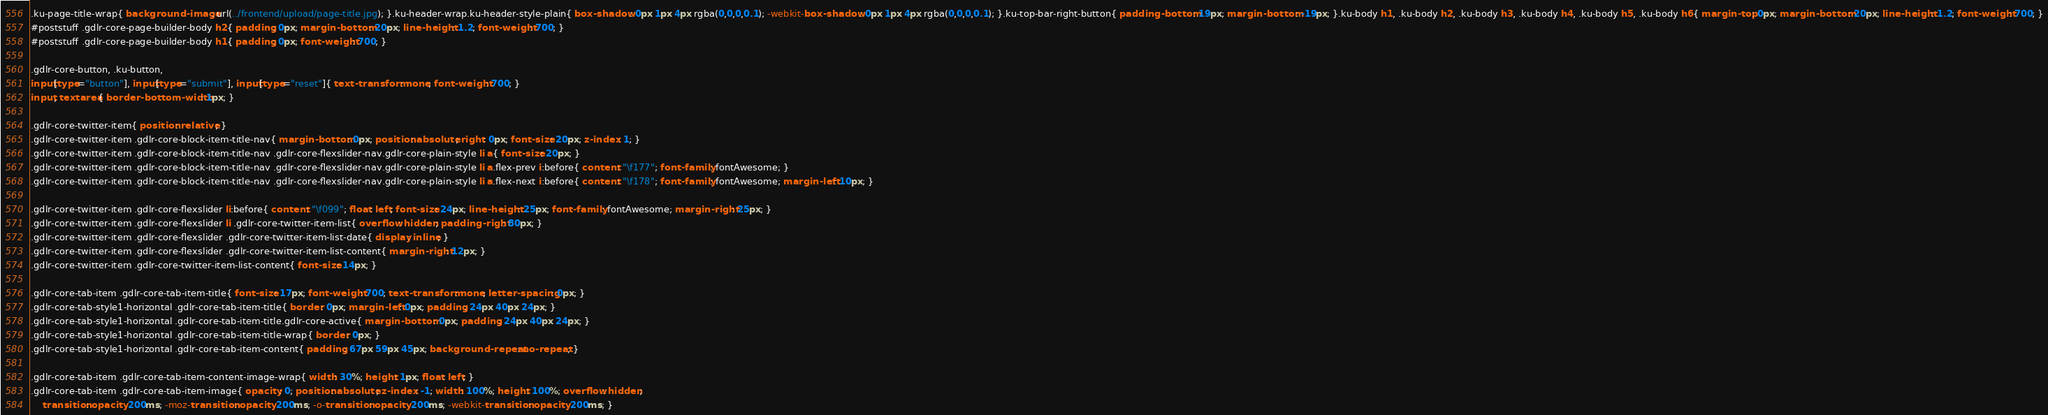Convert code to text. <code><loc_0><loc_0><loc_500><loc_500><_CSS_>.ku-page-title-wrap{ background-image: url(../frontend/upload/page-title.jpg); }.ku-header-wrap.ku-header-style-plain{ box-shadow: 0px 1px 4px rgba(0,0,0,0.1); -webkit-box-shadow: 0px 1px 4px rgba(0,0,0,0.1); }.ku-top-bar-right-button{ padding-bottom: 19px; margin-bottom: -19px; }.ku-body h1, .ku-body h2, .ku-body h3, .ku-body h4, .ku-body h5, .ku-body h6{ margin-top: 0px; margin-bottom: 20px; line-height: 1.2; font-weight: 700; }
#poststuff .gdlr-core-page-builder-body h2{ padding: 0px; margin-bottom: 20px; line-height: 1.2; font-weight: 700; }
#poststuff .gdlr-core-page-builder-body h1{ padding: 0px; font-weight: 700; }

.gdlr-core-button, .ku-button,
input[type="button"], input[type="submit"], input[type="reset"]{ text-transform: none; font-weight: 700; }
input, textarea{ border-bottom-width: 1px; }

.gdlr-core-twitter-item{ position: relative; }
.gdlr-core-twitter-item .gdlr-core-block-item-title-nav{ margin-bottom: 0px; position: absolute; right: 0px; font-size: 20px; z-index: 1; }
.gdlr-core-twitter-item .gdlr-core-block-item-title-nav .gdlr-core-flexslider-nav.gdlr-core-plain-style li a{ font-size: 20px; }
.gdlr-core-twitter-item .gdlr-core-block-item-title-nav .gdlr-core-flexslider-nav.gdlr-core-plain-style li a.flex-prev i:before{ content: "\f177"; font-family: fontAwesome; }
.gdlr-core-twitter-item .gdlr-core-block-item-title-nav .gdlr-core-flexslider-nav.gdlr-core-plain-style li a.flex-next i:before{ content: "\f178"; font-family: fontAwesome; margin-left: 10px; }

.gdlr-core-twitter-item .gdlr-core-flexslider li:before{ content: "\f099"; float: left; font-size: 24px; line-height: 25px; font-family: fontAwesome; margin-right: 25px; }
.gdlr-core-twitter-item .gdlr-core-flexslider li .gdlr-core-twitter-item-list{ overflow: hidden; padding-right: 80px; }
.gdlr-core-twitter-item .gdlr-core-flexslider .gdlr-core-twitter-item-list-date{ display: inline; }
.gdlr-core-twitter-item .gdlr-core-flexslider .gdlr-core-twitter-item-list-content{ margin-right: 12px; }
.gdlr-core-twitter-item .gdlr-core-twitter-item-list-content{ font-size: 14px; }

.gdlr-core-tab-item .gdlr-core-tab-item-title{ font-size: 17px; font-weight: 700; text-transform: none; letter-spacing: 0px; }
.gdlr-core-tab-style1-horizontal .gdlr-core-tab-item-title{ border: 0px; margin-left: 0px; padding: 24px 40px 24px; }
.gdlr-core-tab-style1-horizontal .gdlr-core-tab-item-title.gdlr-core-active{ margin-bottom: 0px; padding: 24px 40px 24px; }
.gdlr-core-tab-style1-horizontal .gdlr-core-tab-item-title-wrap{ border: 0px; }
.gdlr-core-tab-style1-horizontal .gdlr-core-tab-item-content{ padding: 67px 59px 45px; background-repeat: no-repeat; }

.gdlr-core-tab-item .gdlr-core-tab-item-content-image-wrap{ width: 30%; height: 1px; float: left; }
.gdlr-core-tab-item .gdlr-core-tab-item-image{ opacity: 0; position: absolute; z-index: -1; width: 100%; height: 100%; overflow: hidden;
	transition: opacity 200ms; -moz-transition: opacity 200ms; -o-transition: opacity 200ms; -webkit-transition: opacity 200ms; }</code> 